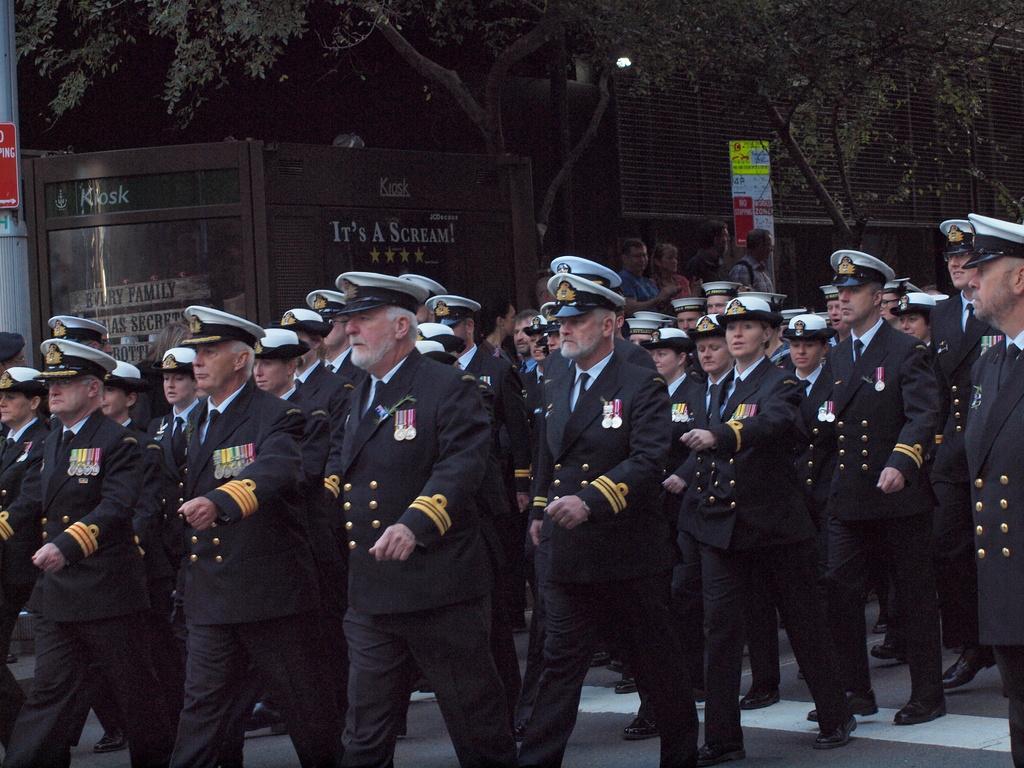In one or two sentences, can you explain what this image depicts? In this picture I can observe some people marching on the road. They are wearing black color coats and white color caps on their heads. In the background I can observe trees. 